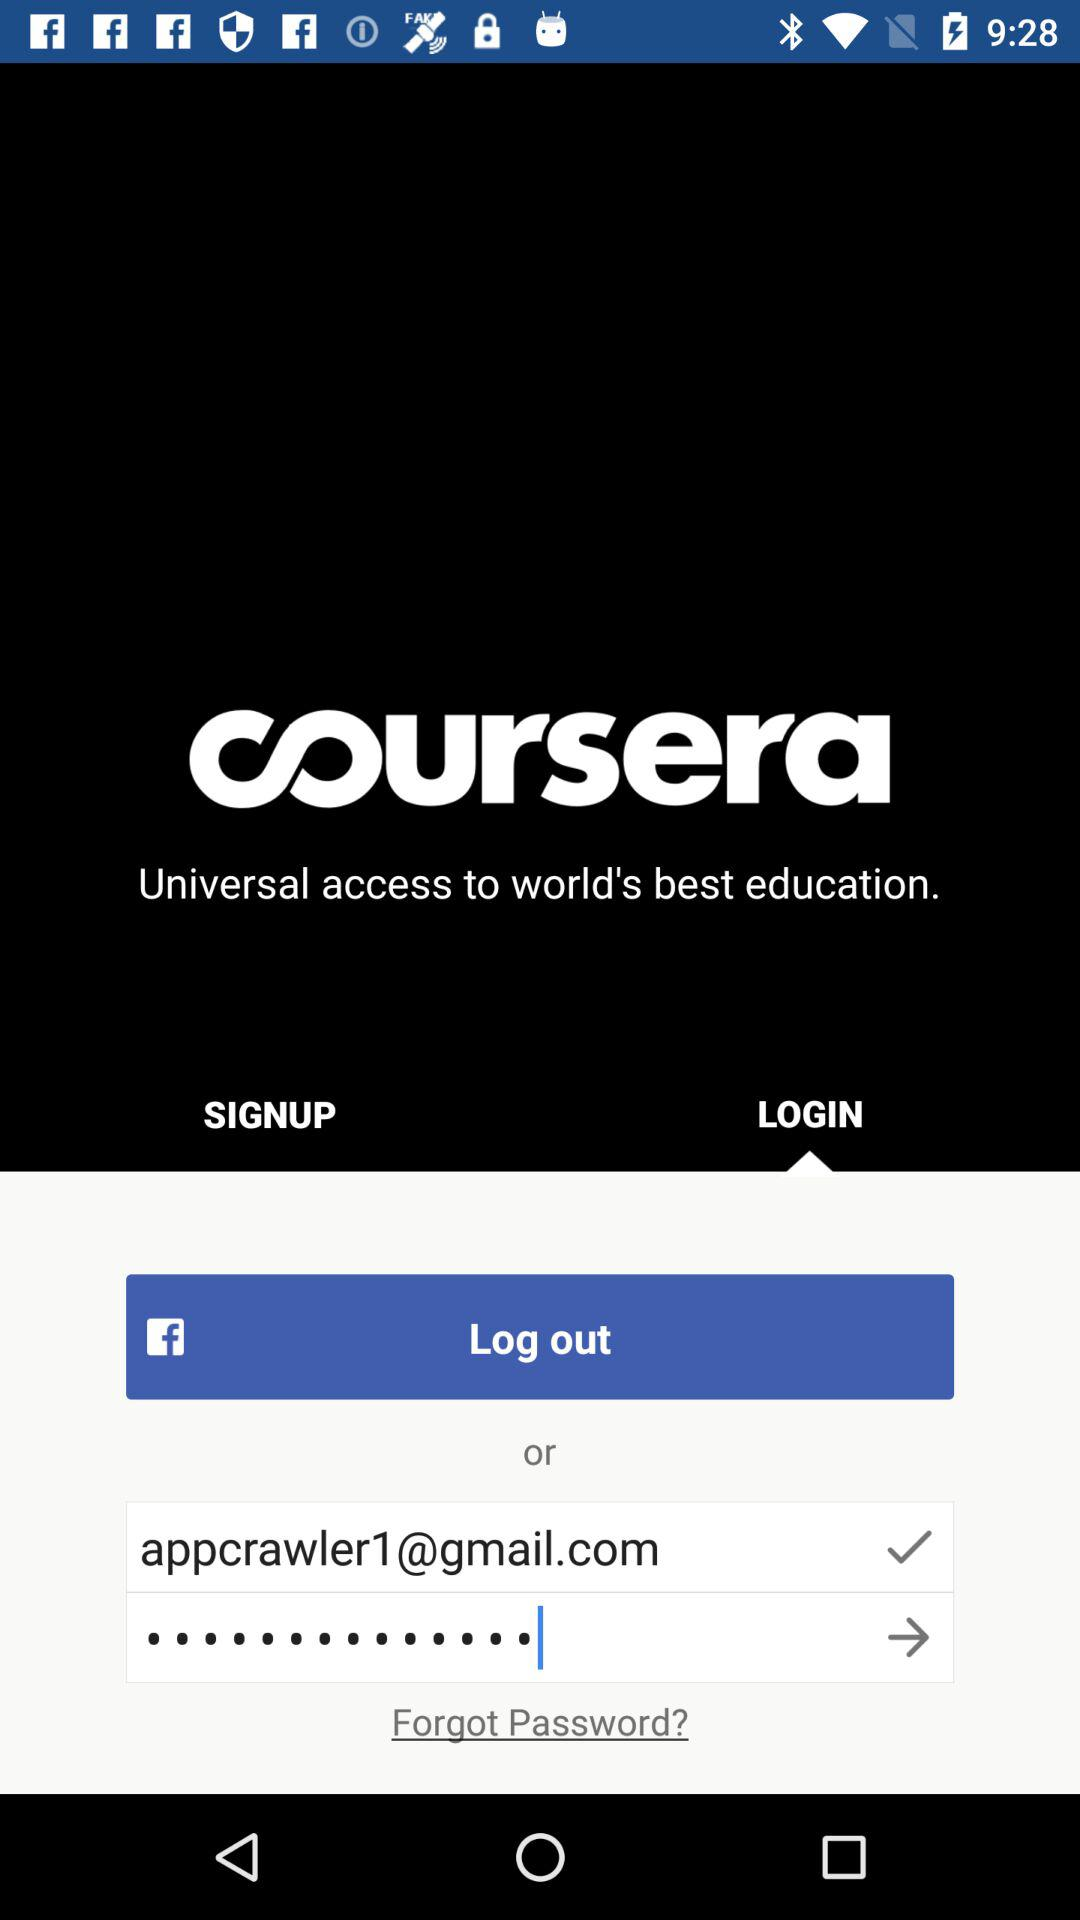How many login options are there?
Answer the question using a single word or phrase. 2 